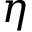<formula> <loc_0><loc_0><loc_500><loc_500>\eta</formula> 